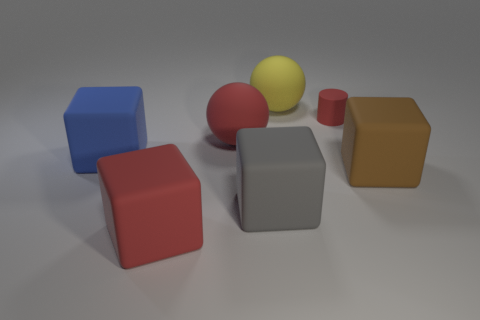Subtract 2 blocks. How many blocks are left? 2 Subtract all gray blocks. How many blocks are left? 3 Add 2 big gray blocks. How many objects exist? 9 Subtract all cyan cubes. Subtract all red cylinders. How many cubes are left? 4 Subtract all cylinders. How many objects are left? 6 Subtract 0 blue cylinders. How many objects are left? 7 Subtract all blue rubber objects. Subtract all red rubber blocks. How many objects are left? 5 Add 1 big red balls. How many big red balls are left? 2 Add 4 large green cubes. How many large green cubes exist? 4 